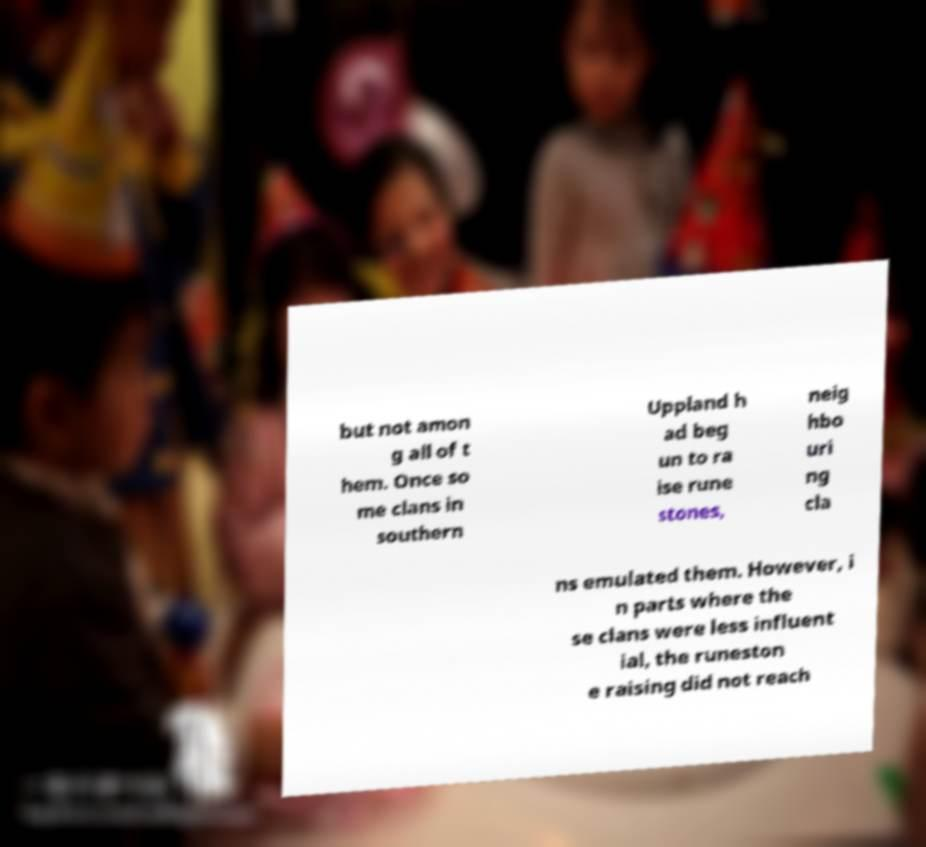For documentation purposes, I need the text within this image transcribed. Could you provide that? but not amon g all of t hem. Once so me clans in southern Uppland h ad beg un to ra ise rune stones, neig hbo uri ng cla ns emulated them. However, i n parts where the se clans were less influent ial, the runeston e raising did not reach 